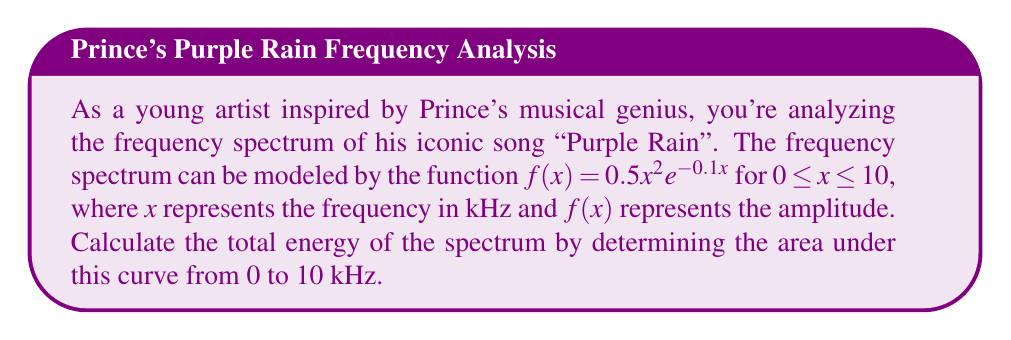Solve this math problem. To find the area under the curve, we need to integrate the function $f(x) = 0.5x^2e^{-0.1x}$ from 0 to 10. Let's approach this step-by-step:

1) We need to evaluate the definite integral:

   $$\int_0^{10} 0.5x^2e^{-0.1x} dx$$

2) This integral doesn't have an elementary antiderivative, so we'll need to use integration by parts twice. Let's set $u = x^2$ and $dv = e^{-0.1x}dx$.

3) First integration by parts:
   
   $\int x^2e^{-0.1x} dx = -10x^2e^{-0.1x} + \int 20xe^{-0.1x} dx$

4) For the remaining integral, let's use integration by parts again with $u = x$ and $dv = e^{-0.1x}dx$:
   
   $\int 20xe^{-0.1x} dx = -200xe^{-0.1x} + \int 200e^{-0.1x} dx$

5) The last integral is straightforward:
   
   $\int 200e^{-0.1x} dx = -2000e^{-0.1x} + C$

6) Putting it all together:

   $\int x^2e^{-0.1x} dx = -10x^2e^{-0.1x} - 200xe^{-0.1x} - 2000e^{-0.1x} + C$

7) Now, let's evaluate this from 0 to 10:

   $$[-10x^2e^{-0.1x} - 200xe^{-0.1x} - 2000e^{-0.1x}]_0^{10}$$

8) Plugging in the limits:
   
   $(-1000e^{-1} - 2000e^{-1} - 2000e^{-1}) - (0 - 0 - 2000)$
   
   $= -5000e^{-1} + 2000$

9) Multiply the result by 0.5 as per the original function:

   $0.5(-5000e^{-1} + 2000) = -2500e^{-1} + 1000$

10) Calculate the final value:

    $-2500/e + 1000 \approx 1079.42$
Answer: The total energy of the spectrum, represented by the area under the curve from 0 to 10 kHz, is approximately 1079.42 (units would depend on how amplitude is measured). 